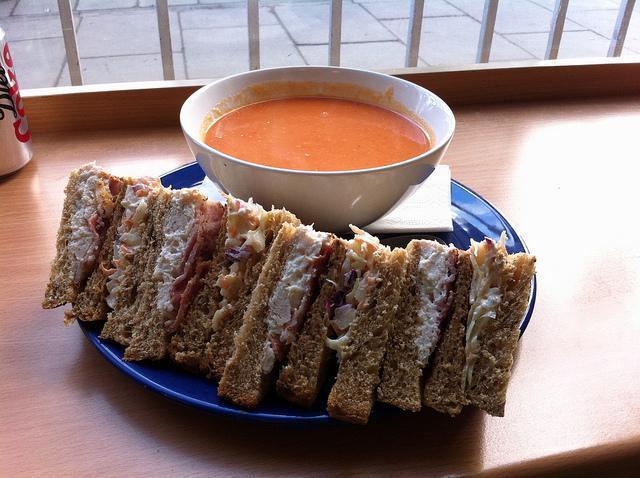How many sandwiches are in the photo?
Give a very brief answer. 8. How many brown horses are there?
Give a very brief answer. 0. 